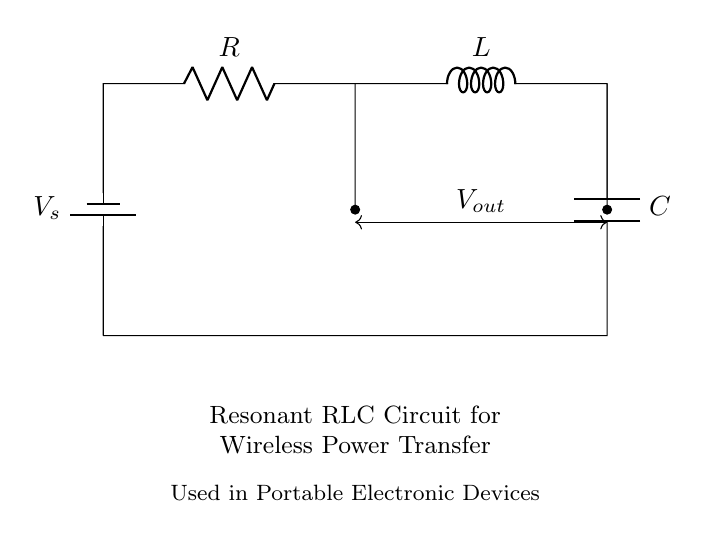What components are present in the circuit? The circuit includes a resistor, an inductor, and a capacitor, as indicated by their respective labels.
Answer: Resistor, Inductor, Capacitor What is the purpose of this circuit? The circuit is designed for wireless power transfer, as mentioned in the text below the circuit diagram.
Answer: Wireless power transfer What is the voltage source denoted in the circuit? The battery symbol represents the voltage source, labeled as V_s in the diagram.
Answer: V_s What type of circuit is this? This is a resonant RLC circuit, as indicated in the label of the circuit diagram.
Answer: Resonant RLC circuit How do the components interact in terms of resonance? The resistor, inductor, and capacitor work together to create a resonant frequency that allows efficient wireless power transfer, where the inductive and capacitive reactances cancel each other at a specific frequency.
Answer: They create a resonant frequency What is the notation used for the output voltage across the capacitor and inductor? The output voltage across the inductor and capacitor is denoted as V_out in the diagram.
Answer: V_out What is the significance of resonance in this RLC circuit? Resonance maximizes energy transfer and efficiency, making it suitable for applications in wireless power systems, particularly in portable electronic devices.
Answer: Maximum energy transfer 